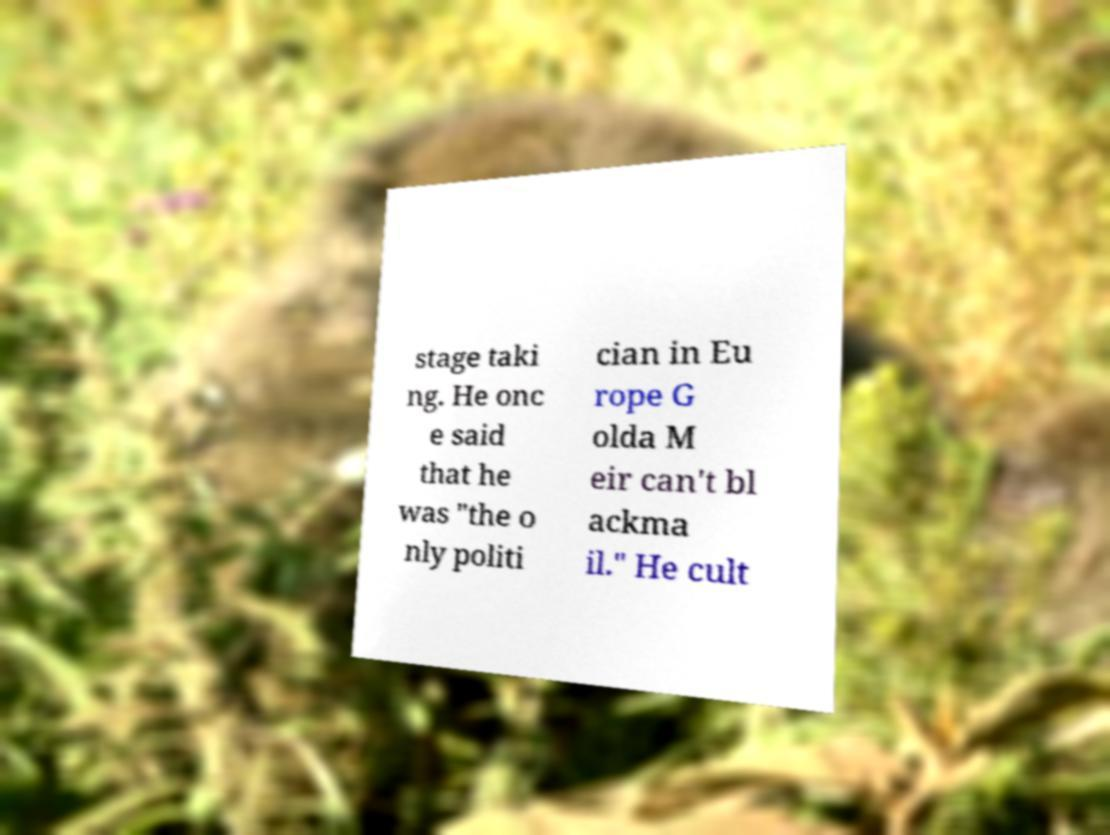Could you extract and type out the text from this image? stage taki ng. He onc e said that he was "the o nly politi cian in Eu rope G olda M eir can't bl ackma il." He cult 